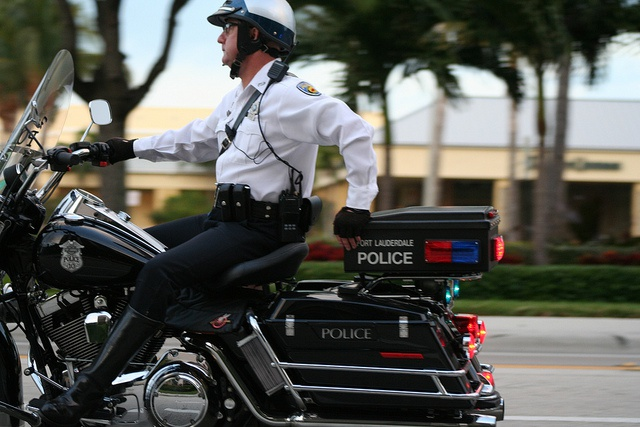Describe the objects in this image and their specific colors. I can see motorcycle in darkgreen, black, gray, darkgray, and lightgray tones, people in darkgreen, black, lavender, darkgray, and gray tones, and cell phone in black, gray, and darkgreen tones in this image. 